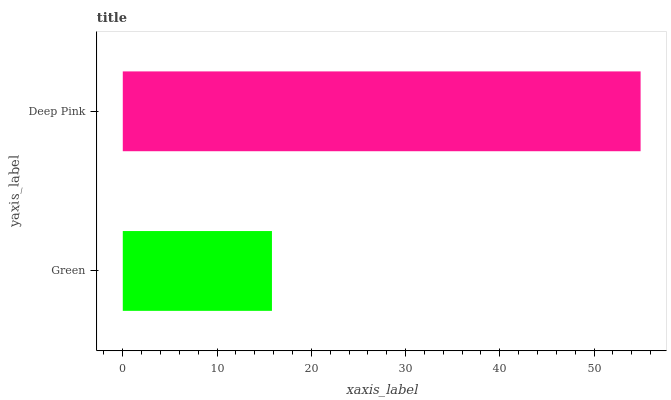Is Green the minimum?
Answer yes or no. Yes. Is Deep Pink the maximum?
Answer yes or no. Yes. Is Deep Pink the minimum?
Answer yes or no. No. Is Deep Pink greater than Green?
Answer yes or no. Yes. Is Green less than Deep Pink?
Answer yes or no. Yes. Is Green greater than Deep Pink?
Answer yes or no. No. Is Deep Pink less than Green?
Answer yes or no. No. Is Deep Pink the high median?
Answer yes or no. Yes. Is Green the low median?
Answer yes or no. Yes. Is Green the high median?
Answer yes or no. No. Is Deep Pink the low median?
Answer yes or no. No. 